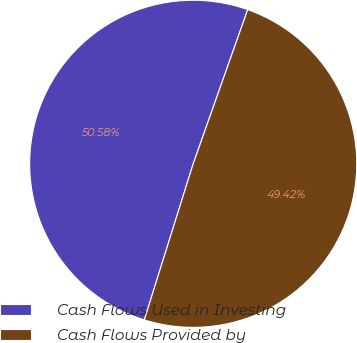<chart> <loc_0><loc_0><loc_500><loc_500><pie_chart><fcel>Cash Flows Used in Investing<fcel>Cash Flows Provided by<nl><fcel>50.58%<fcel>49.42%<nl></chart> 